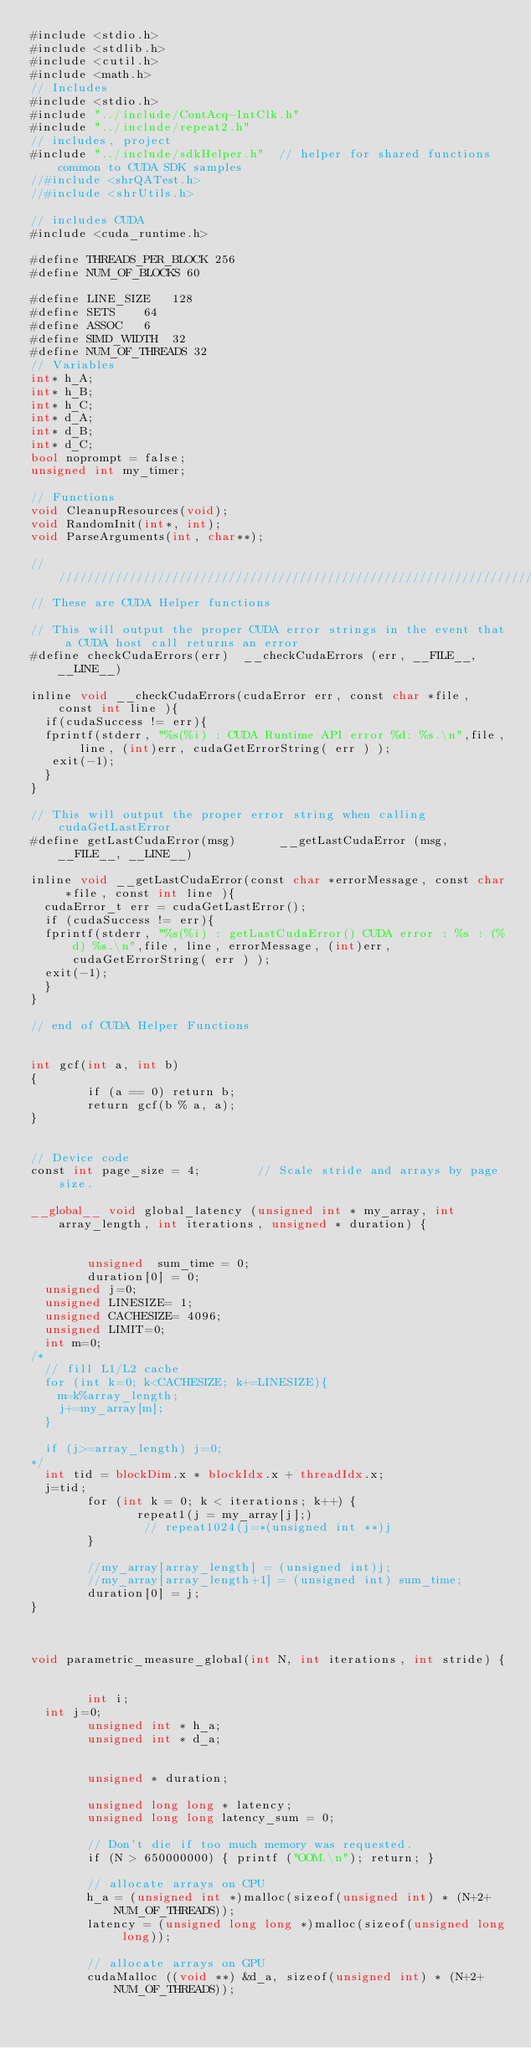Convert code to text. <code><loc_0><loc_0><loc_500><loc_500><_Cuda_>#include <stdio.h>
#include <stdlib.h>
#include <cutil.h>
#include <math.h>
// Includes
#include <stdio.h>
#include "../include/ContAcq-IntClk.h"
#include "../include/repeat2.h"
// includes, project
#include "../include/sdkHelper.h"  // helper for shared functions common to CUDA SDK samples
//#include <shrQATest.h>
//#include <shrUtils.h>

// includes CUDA
#include <cuda_runtime.h>

#define THREADS_PER_BLOCK 256
#define NUM_OF_BLOCKS 60

#define LINE_SIZE 	128
#define SETS		64
#define ASSOC		6
#define SIMD_WIDTH	32
#define NUM_OF_THREADS 32
// Variables
int* h_A;
int* h_B;
int* h_C;
int* d_A;
int* d_B;
int* d_C;
bool noprompt = false;
unsigned int my_timer;

// Functions
void CleanupResources(void);
void RandomInit(int*, int);
void ParseArguments(int, char**);

////////////////////////////////////////////////////////////////////////////////
// These are CUDA Helper functions

// This will output the proper CUDA error strings in the event that a CUDA host call returns an error
#define checkCudaErrors(err)  __checkCudaErrors (err, __FILE__, __LINE__)

inline void __checkCudaErrors(cudaError err, const char *file, const int line ){
  if(cudaSuccess != err){
	fprintf(stderr, "%s(%i) : CUDA Runtime API error %d: %s.\n",file, line, (int)err, cudaGetErrorString( err ) );
	 exit(-1);
  }
}

// This will output the proper error string when calling cudaGetLastError
#define getLastCudaError(msg)      __getLastCudaError (msg, __FILE__, __LINE__)

inline void __getLastCudaError(const char *errorMessage, const char *file, const int line ){
  cudaError_t err = cudaGetLastError();
  if (cudaSuccess != err){
	fprintf(stderr, "%s(%i) : getLastCudaError() CUDA error : %s : (%d) %s.\n",file, line, errorMessage, (int)err, cudaGetErrorString( err ) );
	exit(-1);
  }
}

// end of CUDA Helper Functions


int gcf(int a, int b)
{
        if (a == 0) return b;
        return gcf(b % a, a);
}


// Device code
const int page_size = 4;        // Scale stride and arrays by page size.

__global__ void global_latency (unsigned int * my_array, int array_length, int iterations, unsigned * duration) {

    
        unsigned  sum_time = 0;
        duration[0] = 0;
	unsigned j=0;
	unsigned LINESIZE= 1;
	unsigned CACHESIZE= 4096;
	unsigned LIMIT=0;
	int m=0;
/*
	// fill L1/L2 cache
	for (int k=0; k<CACHESIZE; k+=LINESIZE){
		m=k%array_length;
		j+=my_array[m];
	} 
	       
	if (j>=array_length) j=0;
*/
	int tid = blockDim.x * blockIdx.x + threadIdx.x;
	j=tid;
        for (int k = 0; k < iterations; k++) {
               repeat1(j = my_array[j];)
                // repeat1024(j=*(unsigned int **)j
        }

        //my_array[array_length] = (unsigned int)j;
        //my_array[array_length+1] = (unsigned int) sum_time;
        duration[0] = j;
}



void parametric_measure_global(int N, int iterations, int stride) {


        int i;
	int j=0;
        unsigned int * h_a;
        unsigned int * d_a;


        unsigned * duration;

        unsigned long long * latency;
        unsigned long long latency_sum = 0;

        // Don't die if too much memory was requested.
        if (N > 650000000) { printf ("OOM.\n"); return; }

        // allocate arrays on CPU 
        h_a = (unsigned int *)malloc(sizeof(unsigned int) * (N+2+NUM_OF_THREADS));
        latency = (unsigned long long *)malloc(sizeof(unsigned long long));

        // allocate arrays on GPU 
        cudaMalloc ((void **) &d_a, sizeof(unsigned int) * (N+2+NUM_OF_THREADS));
</code> 